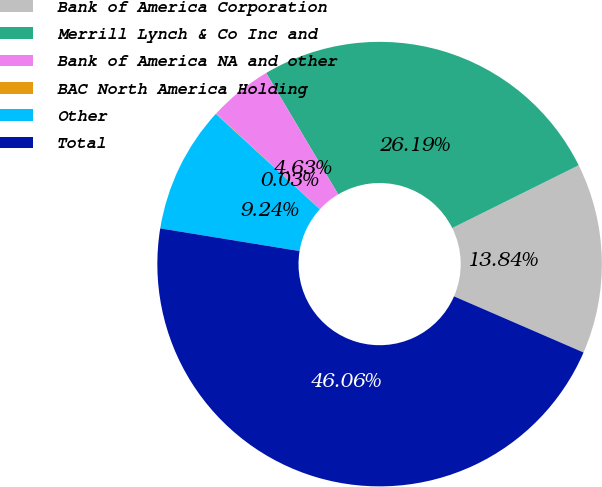Convert chart to OTSL. <chart><loc_0><loc_0><loc_500><loc_500><pie_chart><fcel>Bank of America Corporation<fcel>Merrill Lynch & Co Inc and<fcel>Bank of America NA and other<fcel>BAC North America Holding<fcel>Other<fcel>Total<nl><fcel>13.84%<fcel>26.19%<fcel>4.63%<fcel>0.03%<fcel>9.24%<fcel>46.06%<nl></chart> 